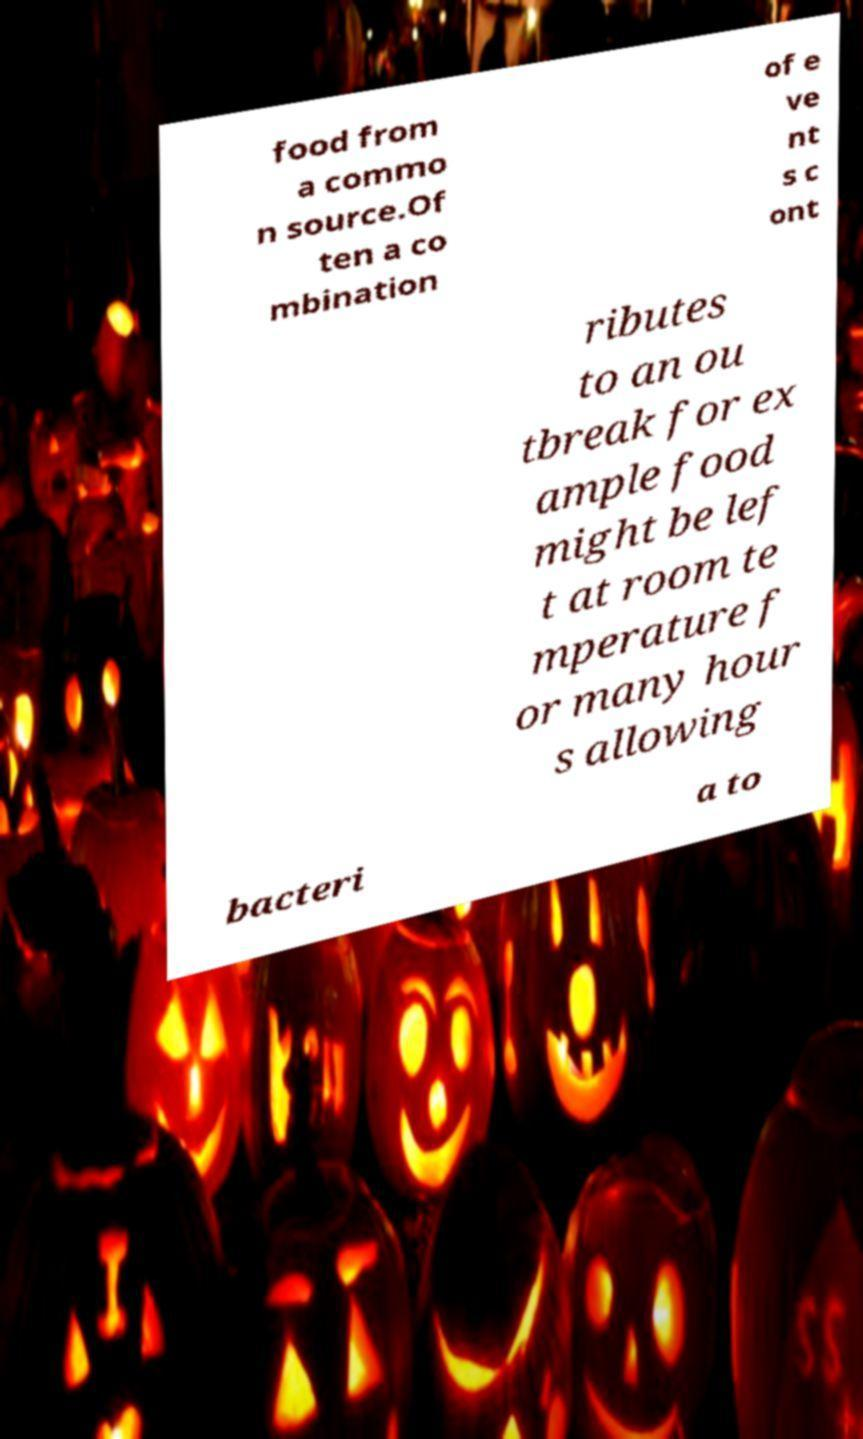Please read and relay the text visible in this image. What does it say? food from a commo n source.Of ten a co mbination of e ve nt s c ont ributes to an ou tbreak for ex ample food might be lef t at room te mperature f or many hour s allowing bacteri a to 